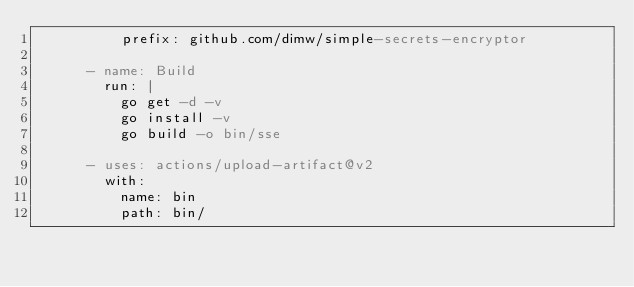Convert code to text. <code><loc_0><loc_0><loc_500><loc_500><_YAML_>          prefix: github.com/dimw/simple-secrets-encryptor

      - name: Build
        run: |
          go get -d -v
          go install -v
          go build -o bin/sse

      - uses: actions/upload-artifact@v2
        with:
          name: bin
          path: bin/
</code> 